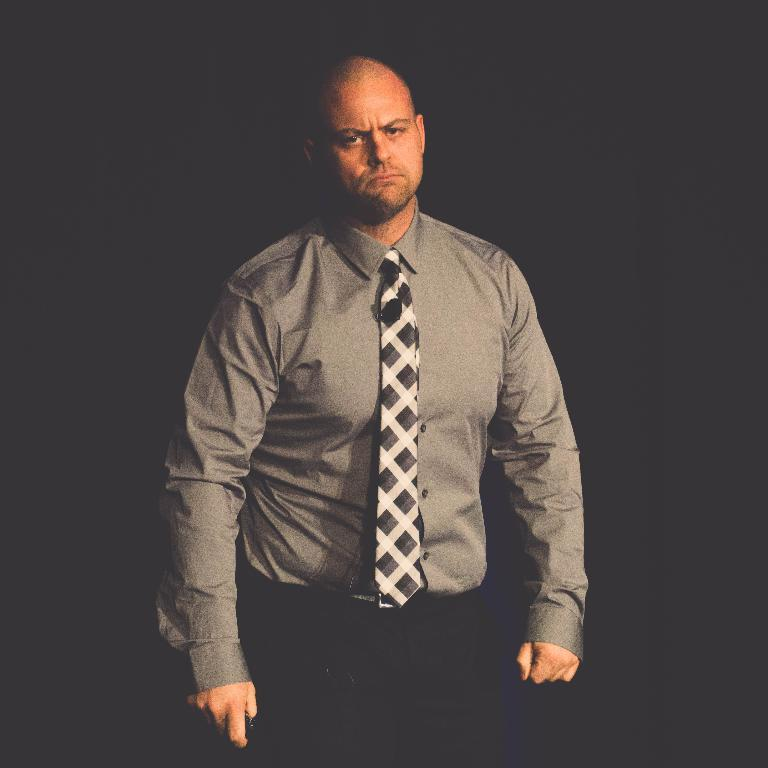What is the main subject of the image? The main subject of the image is a man. What is the man doing in the image? The man is standing in the image. What is the man wearing in the image? The man is wearing a shirt and a tie in the image. What color can be seen in the background of the image? The background of the image has black color. What type of waste can be seen in the image? There is no waste present in the image. Are there any fairies visible in the image? There are no fairies present in the image. 